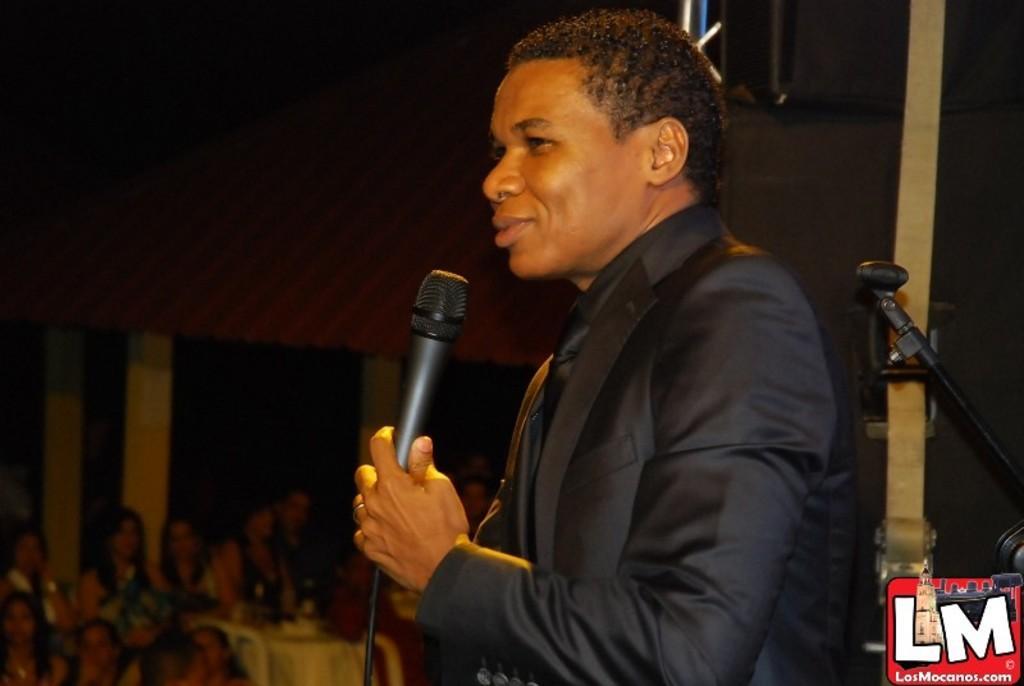In one or two sentences, can you explain what this image depicts? Background is dark. We can see few persons here. We can see a man holding a mike in his hand and smiling. 